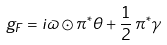<formula> <loc_0><loc_0><loc_500><loc_500>g _ { F } = i \varpi \odot \pi ^ { * } \theta + \frac { 1 } { 2 } \, \pi ^ { * } \gamma</formula> 